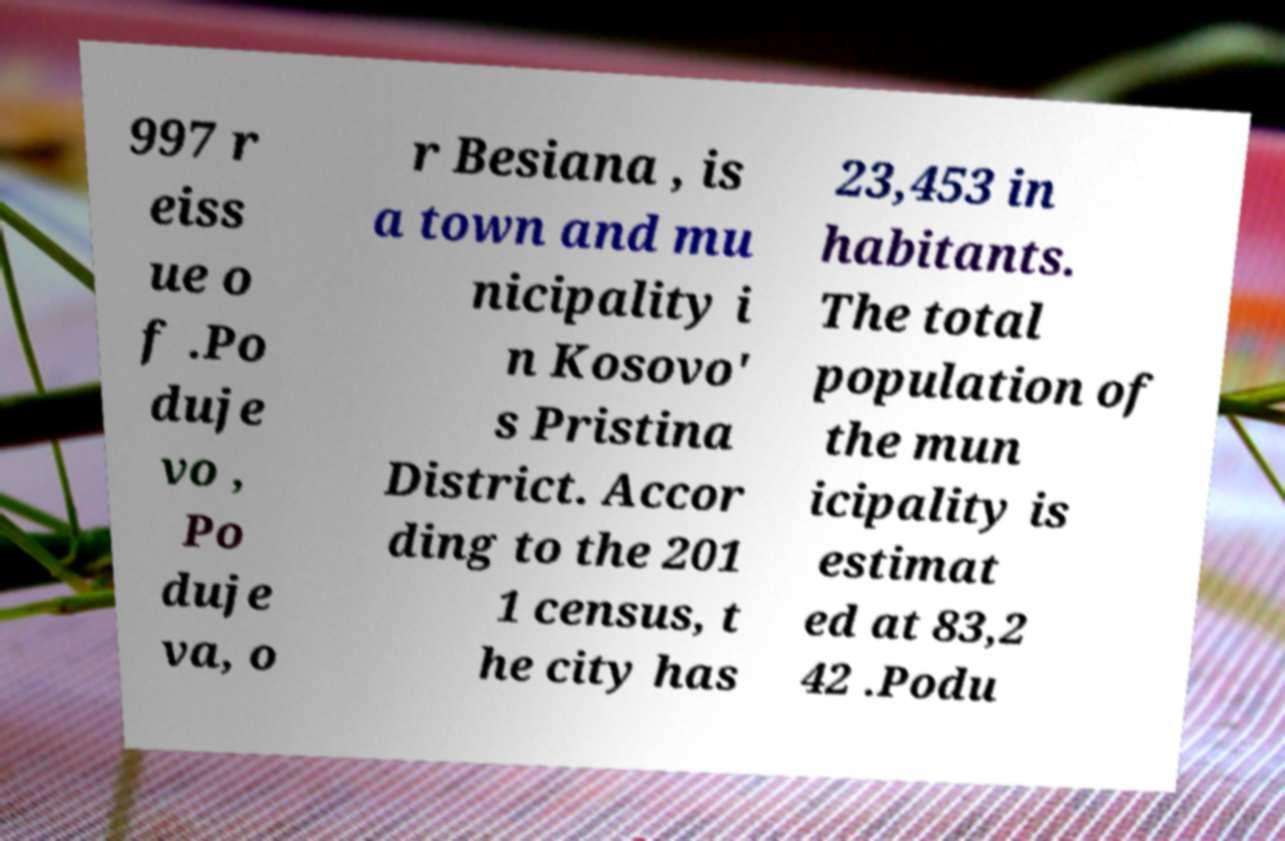Can you accurately transcribe the text from the provided image for me? 997 r eiss ue o f .Po duje vo , Po duje va, o r Besiana , is a town and mu nicipality i n Kosovo' s Pristina District. Accor ding to the 201 1 census, t he city has 23,453 in habitants. The total population of the mun icipality is estimat ed at 83,2 42 .Podu 